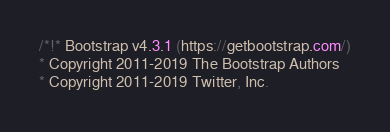Convert code to text. <code><loc_0><loc_0><loc_500><loc_500><_CSS_>/*!* Bootstrap v4.3.1 (https://getbootstrap.com/)
* Copyright 2011-2019 The Bootstrap Authors
* Copyright 2011-2019 Twitter, Inc.</code> 